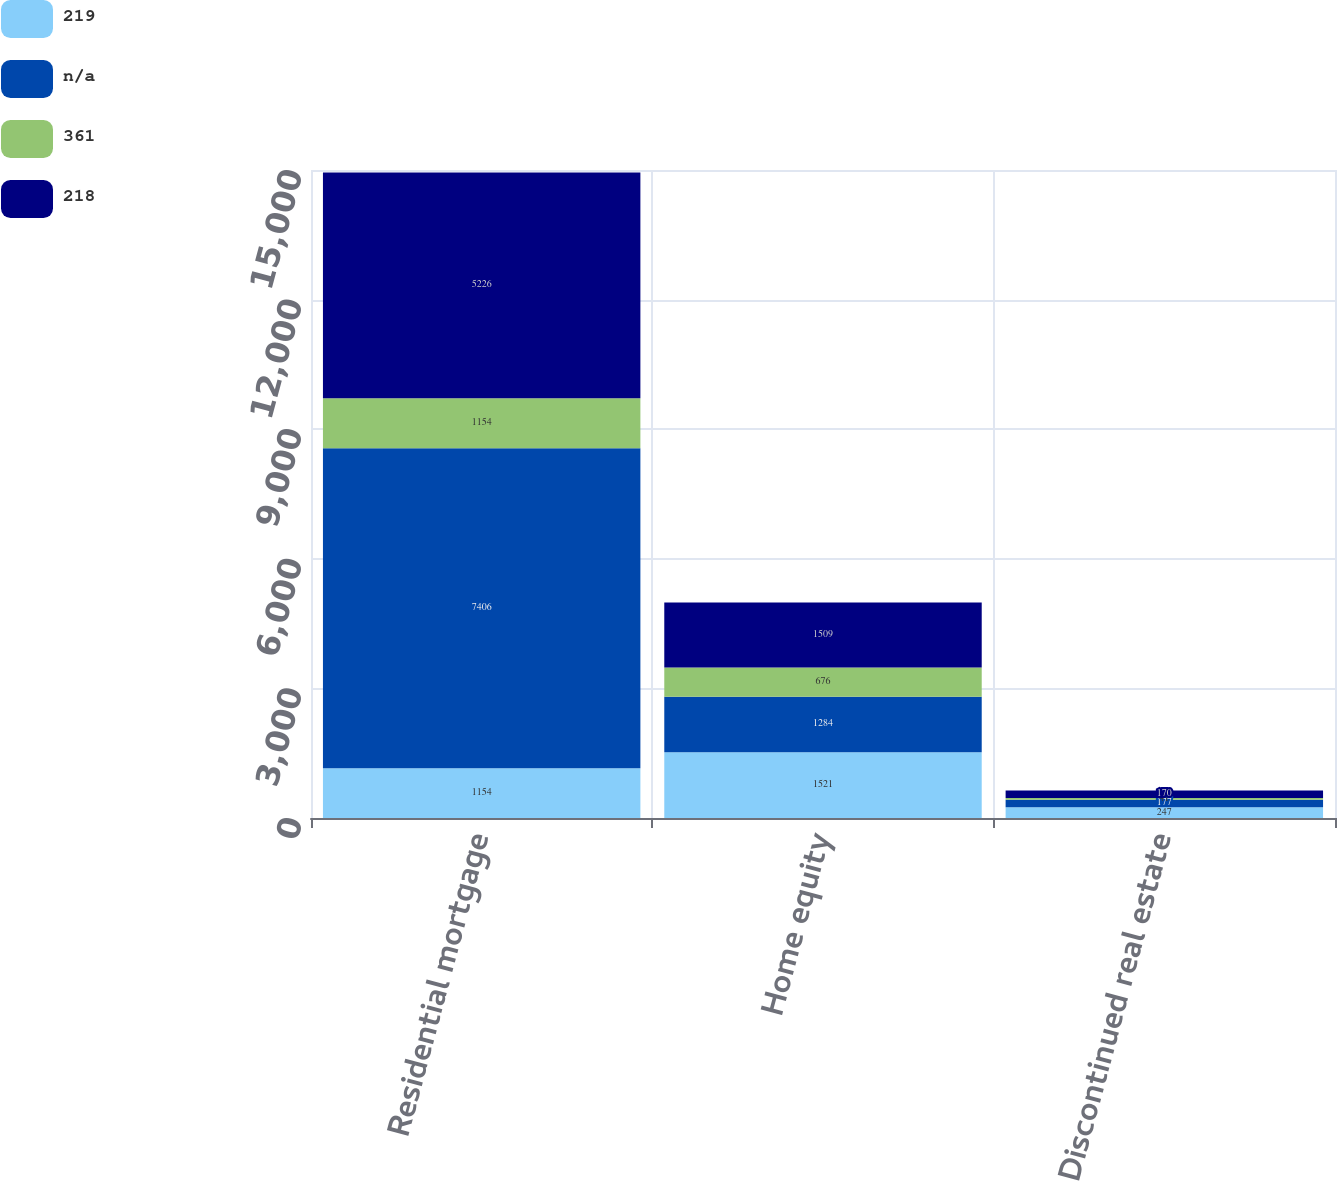Convert chart. <chart><loc_0><loc_0><loc_500><loc_500><stacked_bar_chart><ecel><fcel>Residential mortgage<fcel>Home equity<fcel>Discontinued real estate<nl><fcel>219<fcel>1154<fcel>1521<fcel>247<nl><fcel>nan<fcel>7406<fcel>1284<fcel>177<nl><fcel>361<fcel>1154<fcel>676<fcel>41<nl><fcel>218<fcel>5226<fcel>1509<fcel>170<nl></chart> 